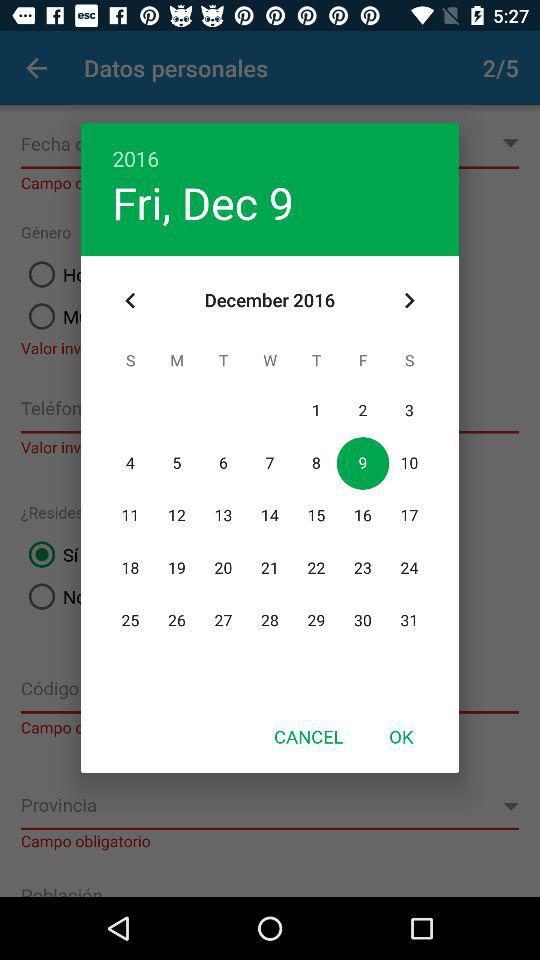What is the day? The day is Friday. 